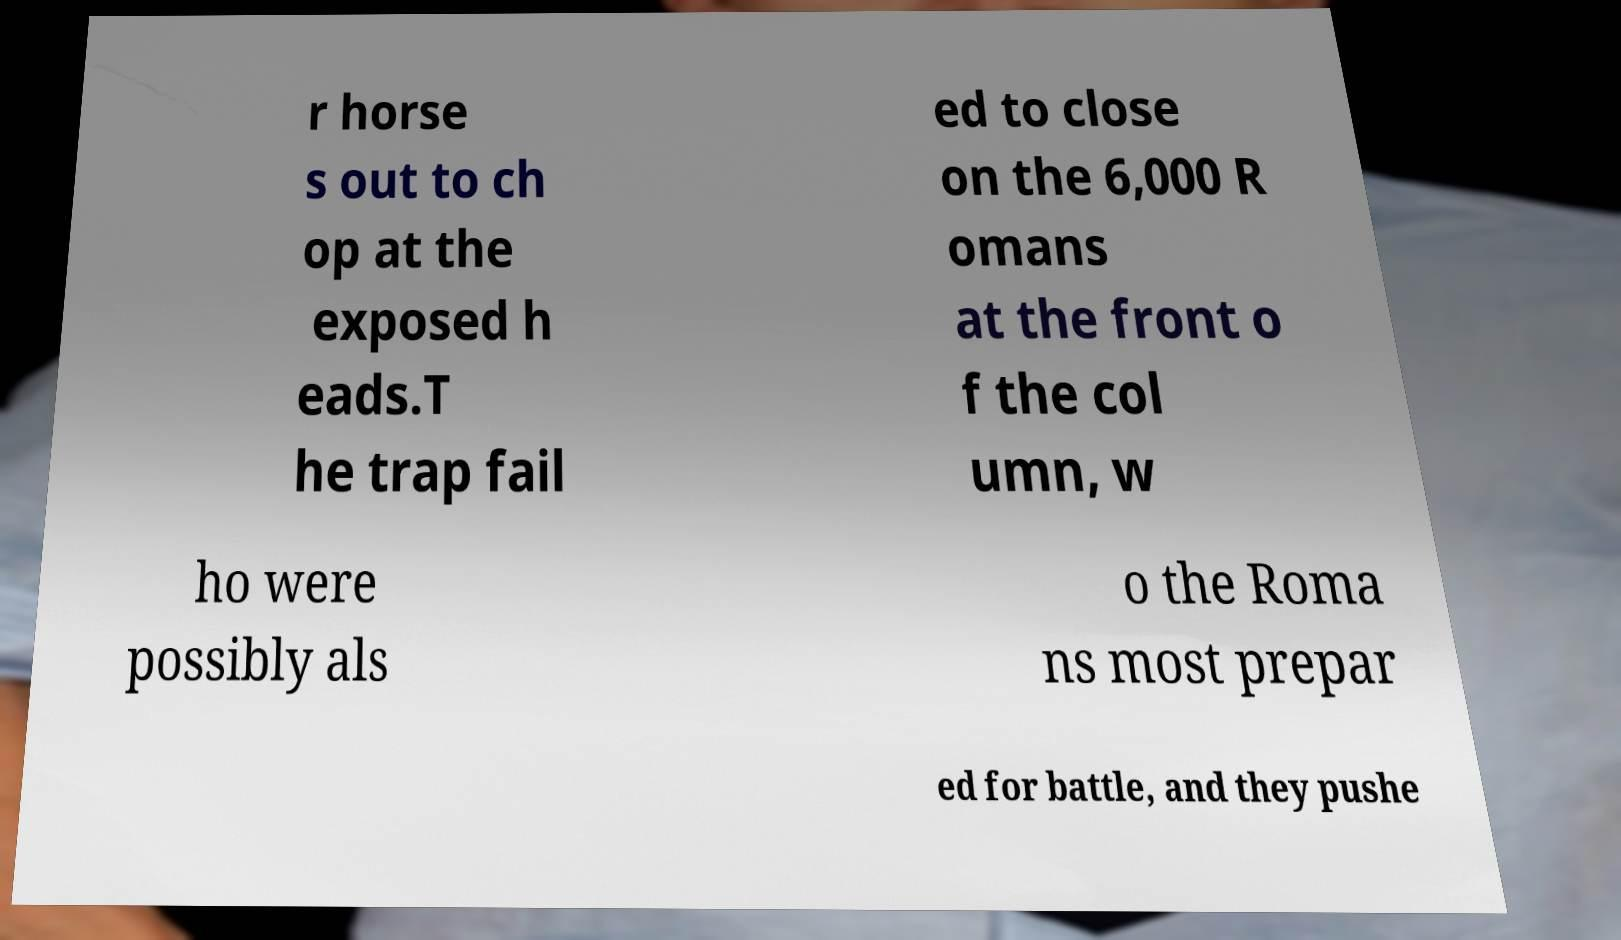Could you extract and type out the text from this image? r horse s out to ch op at the exposed h eads.T he trap fail ed to close on the 6,000 R omans at the front o f the col umn, w ho were possibly als o the Roma ns most prepar ed for battle, and they pushe 